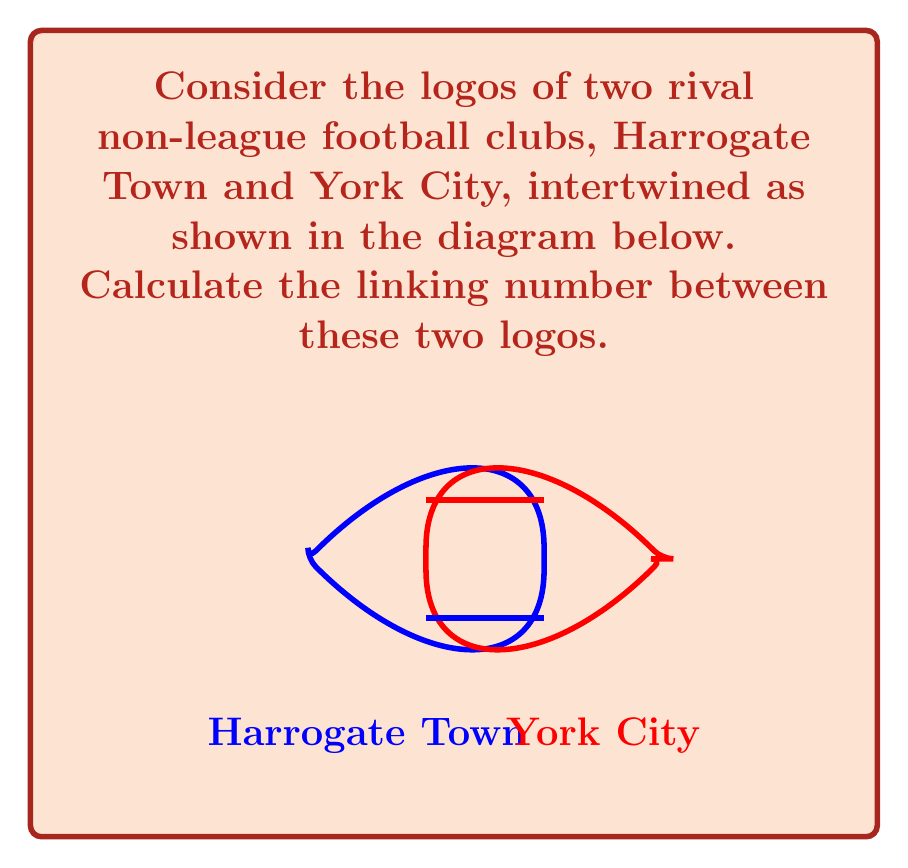Can you solve this math problem? To calculate the linking number between the two intertwined football team logos, we need to follow these steps:

1) Identify the crossings: In the diagram, we can see two crossings where the logos intersect.

2) Assign orientations: We need to assign an arbitrary orientation to each logo. Let's say Harrogate Town's logo (blue) is oriented clockwise, and York City's logo (red) is oriented counterclockwise.

3) Determine the sign of each crossing:
   - At the lower crossing, the blue logo passes over the red logo. As we follow the blue arrow, the red arrow points to the right. This is a positive (+1) crossing.
   - At the upper crossing, the red logo passes over the blue logo. As we follow the red arrow, the blue arrow points to the left. This is also a positive (+1) crossing.

4) Calculate the linking number: The linking number is defined as half the sum of the signs of the crossings.

   $$\text{Linking Number} = \frac{1}{2} \sum \text{(signs of crossings)}$$

   In this case: 
   $$\text{Linking Number} = \frac{1}{2} (+1 + 1) = \frac{1}{2} (2) = 1$$

Therefore, the linking number between the Harrogate Town and York City logos is 1.

This linking number of 1 indicates that the logos are linked once, which could be interpreted as a representation of the rivalry between these two non-league clubs.
Answer: 1 